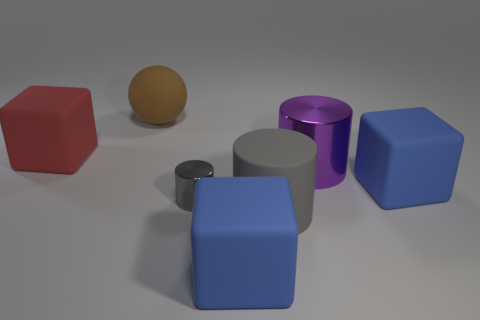Add 3 large things. How many objects exist? 10 Subtract all cylinders. How many objects are left? 4 Add 2 rubber cubes. How many rubber cubes are left? 5 Add 1 large purple rubber things. How many large purple rubber things exist? 1 Subtract 0 red spheres. How many objects are left? 7 Subtract all gray shiny cylinders. Subtract all large gray rubber cylinders. How many objects are left? 5 